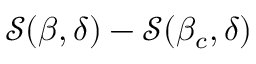<formula> <loc_0><loc_0><loc_500><loc_500>\mathcal { S } ( \beta , \delta ) - \mathcal { S } ( \beta _ { c } , \delta )</formula> 